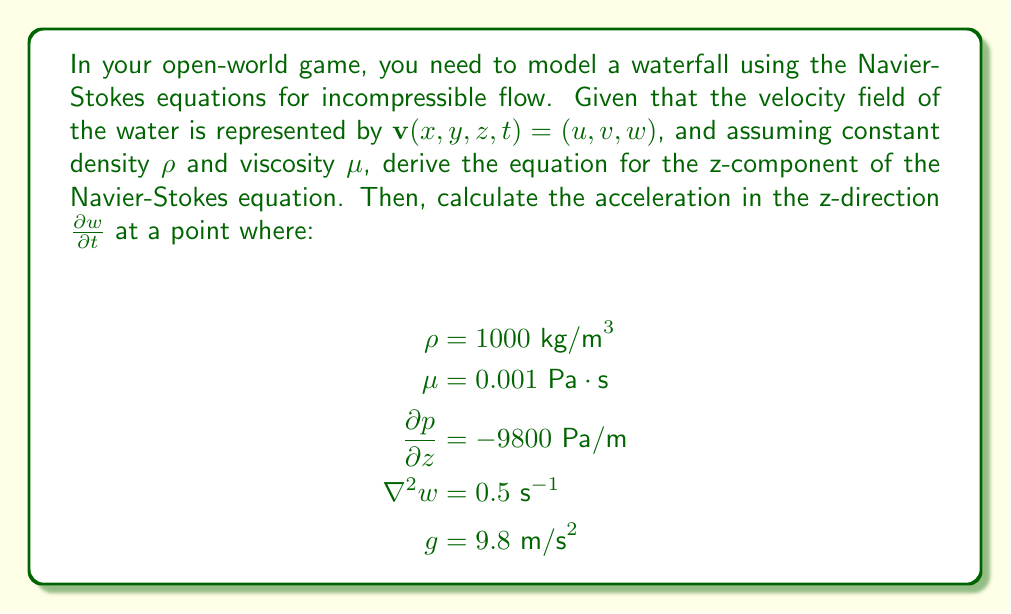Help me with this question. To solve this problem, we'll follow these steps:

1) First, let's recall the general form of the Navier-Stokes equation for incompressible flow:

   $$\rho \frac{D\mathbf{v}}{Dt} = -\nabla p + \mu \nabla^2 \mathbf{v} + \rho \mathbf{g}$$

2) The z-component of this equation is:

   $$\rho \left(\frac{\partial w}{\partial t} + u\frac{\partial w}{\partial x} + v\frac{\partial w}{\partial y} + w\frac{\partial w}{\partial z}\right) = -\frac{\partial p}{\partial z} + \mu \nabla^2 w + \rho g_z$$

3) We're interested in $\frac{\partial w}{\partial t}$, so let's rearrange this equation:

   $$\frac{\partial w}{\partial t} = -u\frac{\partial w}{\partial x} - v\frac{\partial w}{\partial y} - w\frac{\partial w}{\partial z} - \frac{1}{\rho}\frac{\partial p}{\partial z} + \frac{\mu}{\rho} \nabla^2 w + g_z$$

4) Now, let's plug in the given values:
   - $\rho = 1000 \text{ kg/m}^3$
   - $\mu = 0.001 \text{ Pa}\cdot\text{s}$
   - $\frac{\partial p}{\partial z} = -9800 \text{ Pa/m}$
   - $\nabla^2 w = 0.5 \text{ s}^{-1}$
   - $g_z = -g = -9.8 \text{ m/s}^2$ (assuming positive z is upward)

5) Substituting these values:

   $$\frac{\partial w}{\partial t} = -u\frac{\partial w}{\partial x} - v\frac{\partial w}{\partial y} - w\frac{\partial w}{\partial z} - \frac{1}{1000}(-9800) + \frac{0.001}{1000} (0.5) - 9.8$$

6) Simplifying:

   $$\frac{\partial w}{\partial t} = -u\frac{\partial w}{\partial x} - v\frac{\partial w}{\partial y} - w\frac{\partial w}{\partial z} + 9.8 + 0.0000005 - 9.8$$

7) The $9.8$ and $-9.8$ cancel out, leaving:

   $$\frac{\partial w}{\partial t} = -u\frac{\partial w}{\partial x} - v\frac{\partial w}{\partial y} - w\frac{\partial w}{\partial z} + 0.0000005$$

This is our final equation for $\frac{\partial w}{\partial t}$. To get a specific value, we would need to know the values of $u$, $v$, $w$, and their partial derivatives at the point of interest.
Answer: $$\frac{\partial w}{\partial t} = -u\frac{\partial w}{\partial x} - v\frac{\partial w}{\partial y} - w\frac{\partial w}{\partial z} + 0.0000005 \text{ m/s}^2$$ 